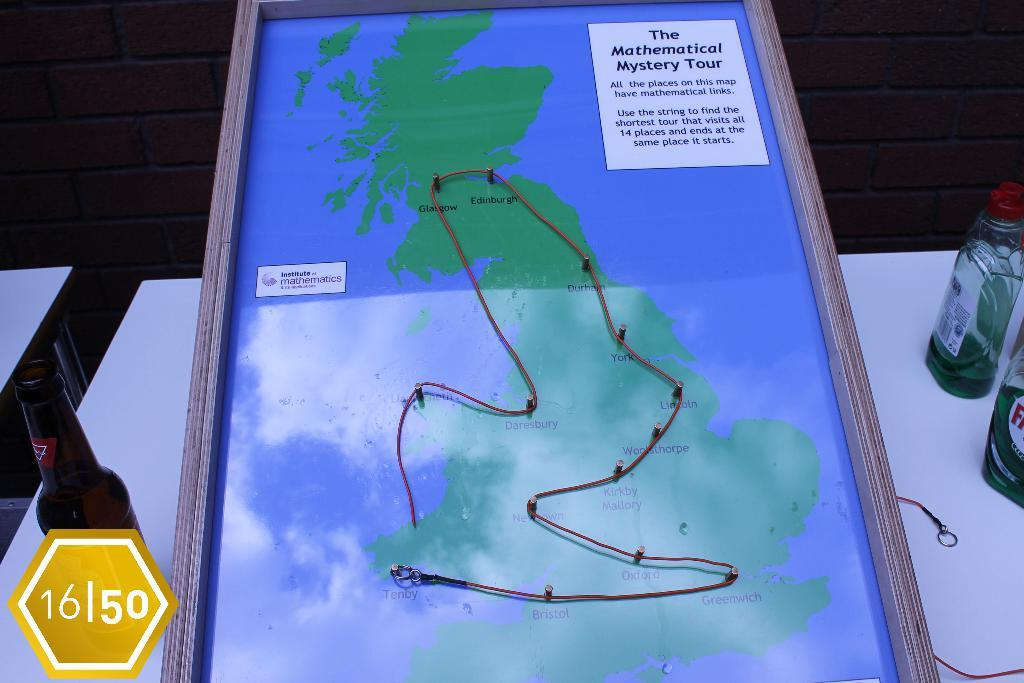Provide a one-sentence caption for the provided image. A map of the Mathematical Mystery Tour in the UK is shown. 